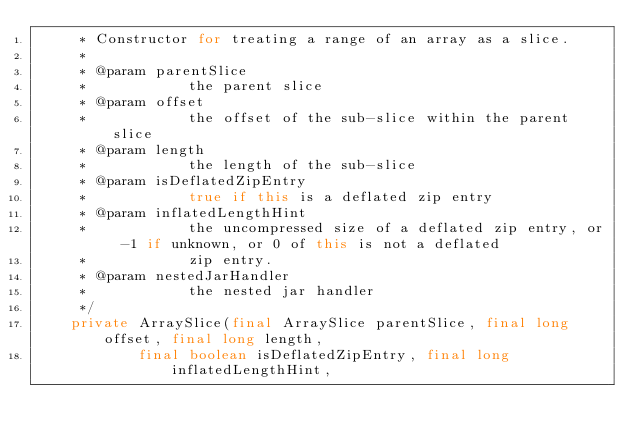<code> <loc_0><loc_0><loc_500><loc_500><_Java_>     * Constructor for treating a range of an array as a slice.
     *
     * @param parentSlice
     *            the parent slice
     * @param offset
     *            the offset of the sub-slice within the parent slice
     * @param length
     *            the length of the sub-slice
     * @param isDeflatedZipEntry
     *            true if this is a deflated zip entry
     * @param inflatedLengthHint
     *            the uncompressed size of a deflated zip entry, or -1 if unknown, or 0 of this is not a deflated
     *            zip entry.
     * @param nestedJarHandler
     *            the nested jar handler
     */
    private ArraySlice(final ArraySlice parentSlice, final long offset, final long length,
            final boolean isDeflatedZipEntry, final long inflatedLengthHint,</code> 